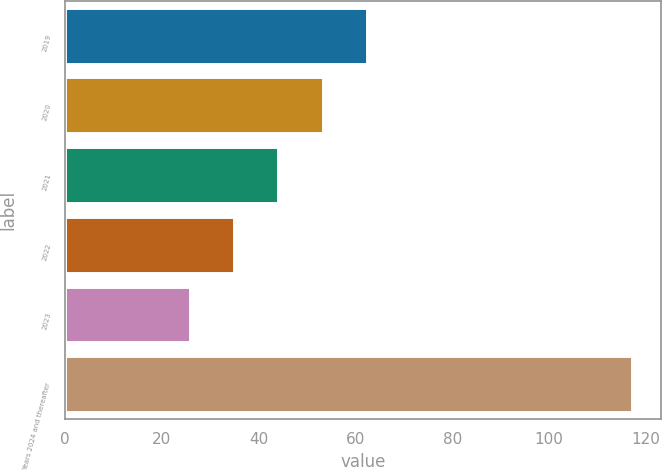<chart> <loc_0><loc_0><loc_500><loc_500><bar_chart><fcel>2019<fcel>2020<fcel>2021<fcel>2022<fcel>2023<fcel>Years 2024 and thereafter<nl><fcel>62.36<fcel>53.22<fcel>44.08<fcel>34.94<fcel>25.8<fcel>117.2<nl></chart> 